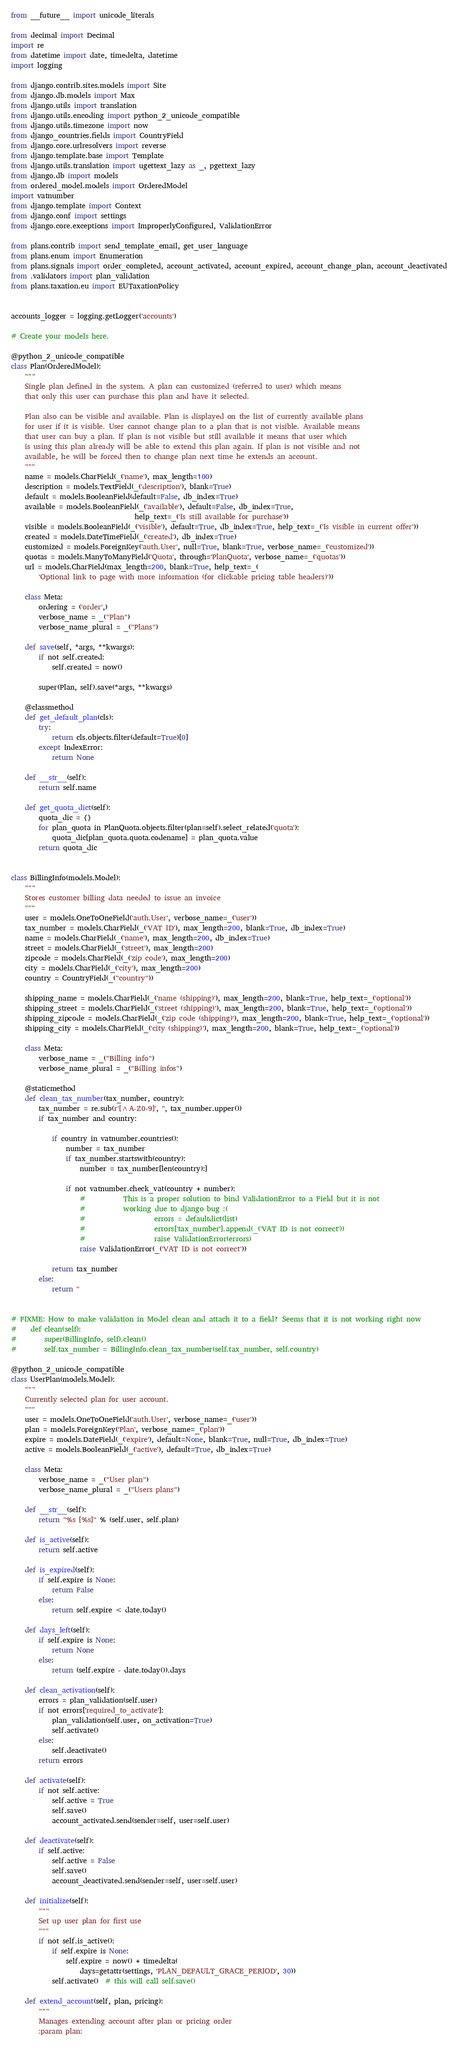<code> <loc_0><loc_0><loc_500><loc_500><_Python_>from __future__ import unicode_literals

from decimal import Decimal
import re
from datetime import date, timedelta, datetime
import logging

from django.contrib.sites.models import Site
from django.db.models import Max
from django.utils import translation
from django.utils.encoding import python_2_unicode_compatible
from django.utils.timezone import now
from django_countries.fields import CountryField
from django.core.urlresolvers import reverse
from django.template.base import Template
from django.utils.translation import ugettext_lazy as _, pgettext_lazy
from django.db import models
from ordered_model.models import OrderedModel
import vatnumber
from django.template import Context
from django.conf import settings
from django.core.exceptions import ImproperlyConfigured, ValidationError

from plans.contrib import send_template_email, get_user_language
from plans.enum import Enumeration
from plans.signals import order_completed, account_activated, account_expired, account_change_plan, account_deactivated
from .validators import plan_validation
from plans.taxation.eu import EUTaxationPolicy


accounts_logger = logging.getLogger('accounts')

# Create your models here.

@python_2_unicode_compatible
class Plan(OrderedModel):
    """
    Single plan defined in the system. A plan can customized (referred to user) which means
    that only this user can purchase this plan and have it selected.

    Plan also can be visible and available. Plan is displayed on the list of currently available plans
    for user if it is visible. User cannot change plan to a plan that is not visible. Available means
    that user can buy a plan. If plan is not visible but still available it means that user which
    is using this plan already will be able to extend this plan again. If plan is not visible and not
    available, he will be forced then to change plan next time he extends an account.
    """
    name = models.CharField(_('name'), max_length=100)
    description = models.TextField(_('description'), blank=True)
    default = models.BooleanField(default=False, db_index=True)
    available = models.BooleanField(_('available'), default=False, db_index=True,
                                    help_text=_('Is still available for purchase'))
    visible = models.BooleanField(_('visible'), default=True, db_index=True, help_text=_('Is visible in current offer'))
    created = models.DateTimeField(_('created'), db_index=True)
    customized = models.ForeignKey('auth.User', null=True, blank=True, verbose_name=_('customized'))
    quotas = models.ManyToManyField('Quota', through='PlanQuota', verbose_name=_('quotas'))
    url = models.CharField(max_length=200, blank=True, help_text=_(
        'Optional link to page with more information (for clickable pricing table headers)'))

    class Meta:
        ordering = ('order',)
        verbose_name = _("Plan")
        verbose_name_plural = _("Plans")

    def save(self, *args, **kwargs):
        if not self.created:
            self.created = now()

        super(Plan, self).save(*args, **kwargs)

    @classmethod
    def get_default_plan(cls):
        try:
            return cls.objects.filter(default=True)[0]
        except IndexError:
            return None

    def __str__(self):
        return self.name

    def get_quota_dict(self):
        quota_dic = {}
        for plan_quota in PlanQuota.objects.filter(plan=self).select_related('quota'):
            quota_dic[plan_quota.quota.codename] = plan_quota.value
        return quota_dic


class BillingInfo(models.Model):
    """
    Stores customer billing data needed to issue an invoice
    """
    user = models.OneToOneField('auth.User', verbose_name=_('user'))
    tax_number = models.CharField(_('VAT ID'), max_length=200, blank=True, db_index=True)
    name = models.CharField(_('name'), max_length=200, db_index=True)
    street = models.CharField(_('street'), max_length=200)
    zipcode = models.CharField(_('zip code'), max_length=200)
    city = models.CharField(_('city'), max_length=200)
    country = CountryField(_("country"))

    shipping_name = models.CharField(_('name (shipping)'), max_length=200, blank=True, help_text=_('optional'))
    shipping_street = models.CharField(_('street (shipping)'), max_length=200, blank=True, help_text=_('optional'))
    shipping_zipcode = models.CharField(_('zip code (shipping)'), max_length=200, blank=True, help_text=_('optional'))
    shipping_city = models.CharField(_('city (shipping)'), max_length=200, blank=True, help_text=_('optional'))

    class Meta:
        verbose_name = _("Billing info")
        verbose_name_plural = _("Billing infos")

    @staticmethod
    def clean_tax_number(tax_number, country):
        tax_number = re.sub(r'[^A-Z0-9]', '', tax_number.upper())
        if tax_number and country:

            if country in vatnumber.countries():
                number = tax_number
                if tax_number.startswith(country):
                    number = tax_number[len(country):]

                if not vatnumber.check_vat(country + number):
                    #           This is a proper solution to bind ValidationError to a Field but it is not
                    #           working due to django bug :(
                    #                    errors = defaultdict(list)
                    #                    errors['tax_number'].append(_('VAT ID is not correct'))
                    #                    raise ValidationError(errors)
                    raise ValidationError(_('VAT ID is not correct'))

            return tax_number
        else:
            return ''


# FIXME: How to make validation in Model clean and attach it to a field? Seems that it is not working right now
#    def clean(self):
#        super(BillingInfo, self).clean()
#        self.tax_number = BillingInfo.clean_tax_number(self.tax_number, self.country)

@python_2_unicode_compatible
class UserPlan(models.Model):
    """
    Currently selected plan for user account.
    """
    user = models.OneToOneField('auth.User', verbose_name=_('user'))
    plan = models.ForeignKey('Plan', verbose_name=_('plan'))
    expire = models.DateField(_('expire'), default=None, blank=True, null=True, db_index=True)
    active = models.BooleanField(_('active'), default=True, db_index=True)

    class Meta:
        verbose_name = _("User plan")
        verbose_name_plural = _("Users plans")

    def __str__(self):
        return "%s [%s]" % (self.user, self.plan)

    def is_active(self):
        return self.active

    def is_expired(self):
        if self.expire is None:
            return False
        else:
            return self.expire < date.today()

    def days_left(self):
        if self.expire is None:
            return None
        else:
            return (self.expire - date.today()).days

    def clean_activation(self):
        errors = plan_validation(self.user)
        if not errors['required_to_activate']:
            plan_validation(self.user, on_activation=True)
            self.activate()
        else:
            self.deactivate()
        return errors

    def activate(self):
        if not self.active:
            self.active = True
            self.save()
            account_activated.send(sender=self, user=self.user)

    def deactivate(self):
        if self.active:
            self.active = False
            self.save()
            account_deactivated.send(sender=self, user=self.user)

    def initialize(self):
        """
        Set up user plan for first use
        """
        if not self.is_active():
            if self.expire is None:
                self.expire = now() + timedelta(
                    days=getattr(settings, 'PLAN_DEFAULT_GRACE_PERIOD', 30))
            self.activate()  # this will call self.save()

    def extend_account(self, plan, pricing):
        """
        Manages extending account after plan or pricing order
        :param plan:</code> 